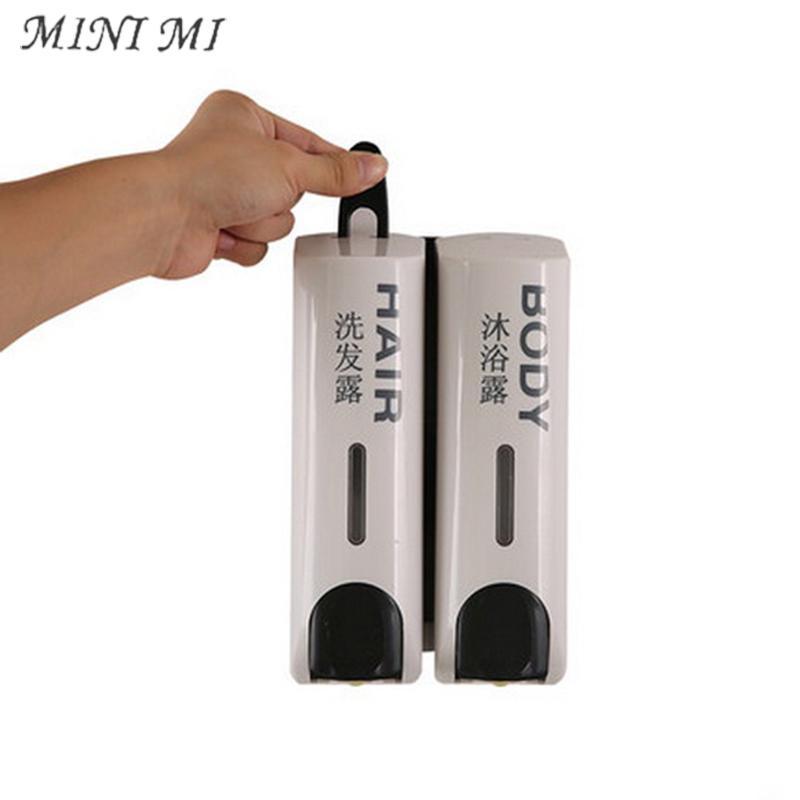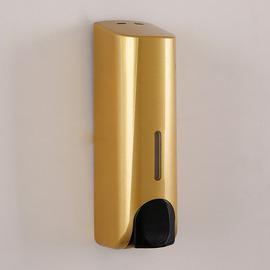The first image is the image on the left, the second image is the image on the right. Considering the images on both sides, is "There are two cleaning products on the left and three on the right." valid? Answer yes or no. No. The first image is the image on the left, the second image is the image on the right. Assess this claim about the two images: "An image shows three side-by-side gold dispensers with black push buttons.". Correct or not? Answer yes or no. No. 